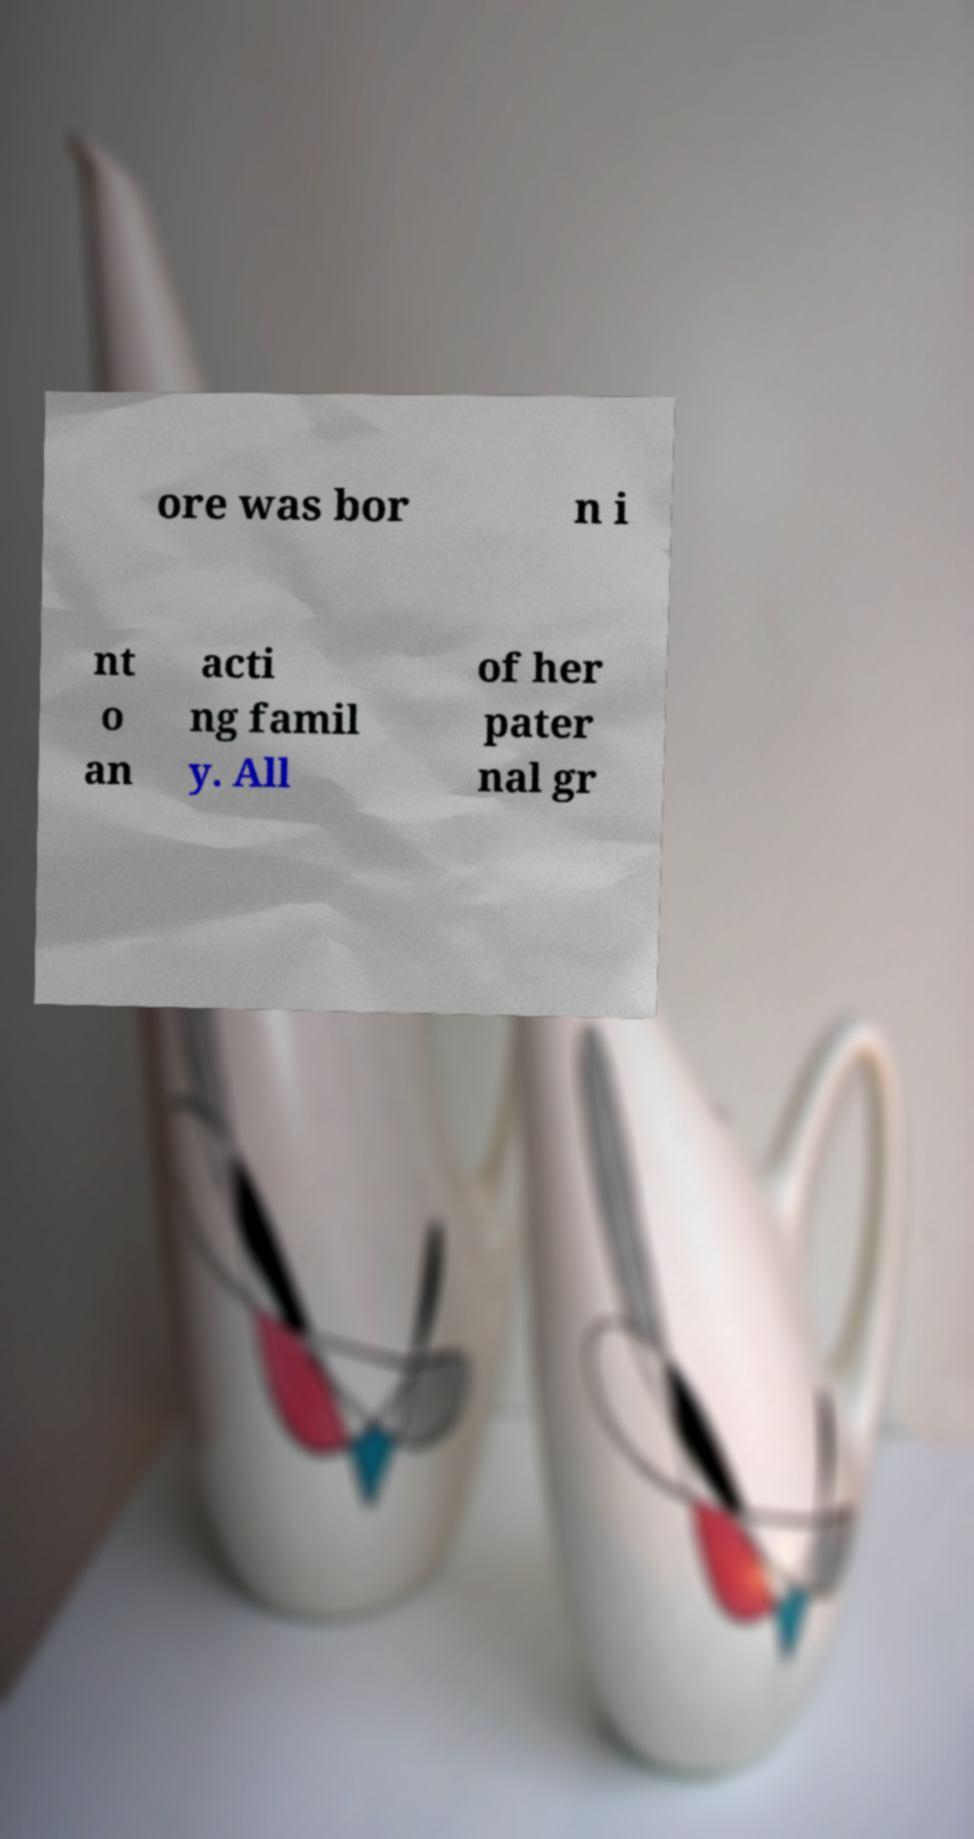I need the written content from this picture converted into text. Can you do that? ore was bor n i nt o an acti ng famil y. All of her pater nal gr 